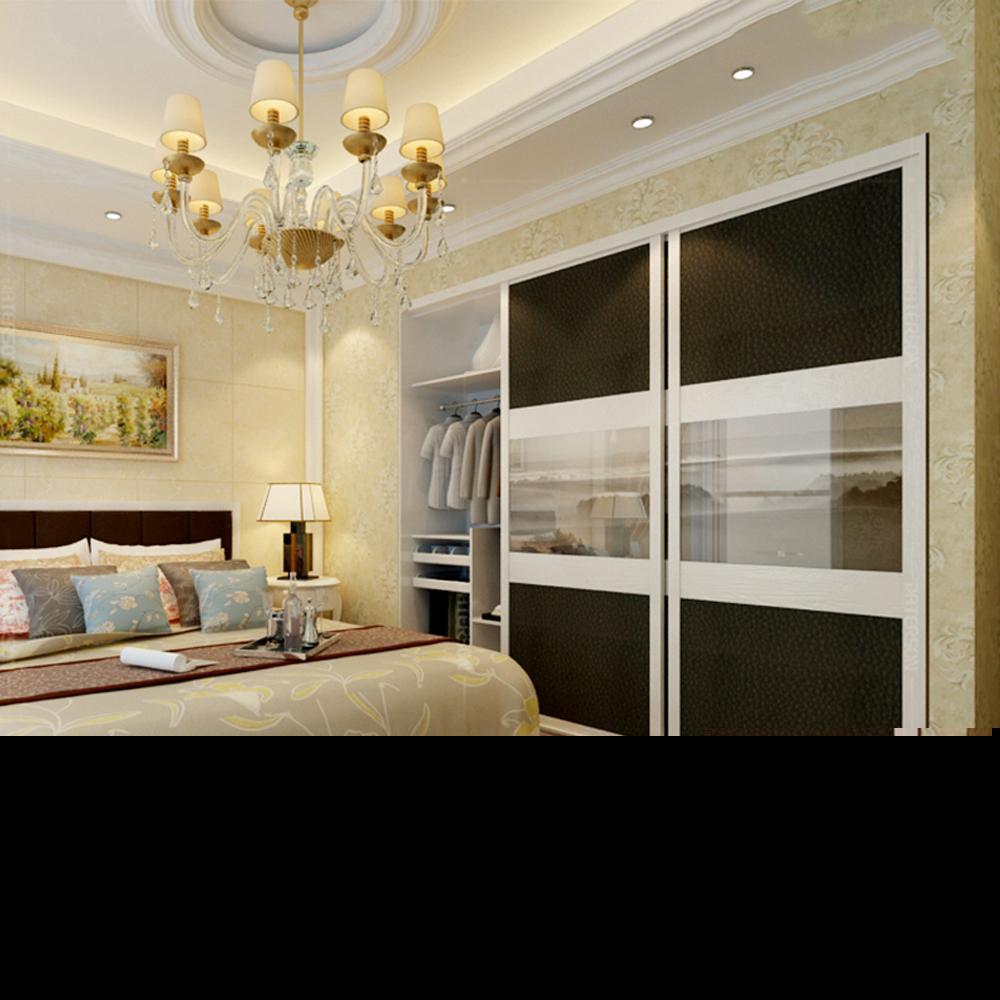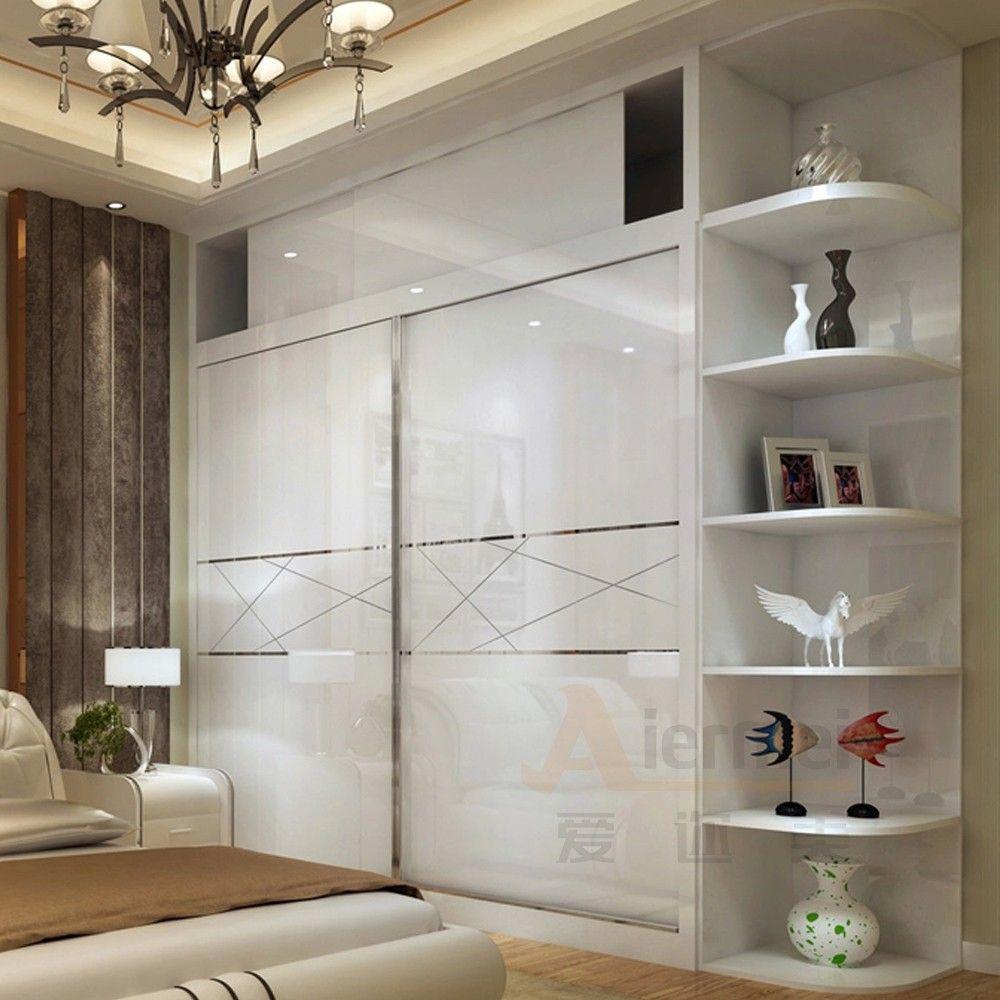The first image is the image on the left, the second image is the image on the right. Considering the images on both sides, is "The right image shows at least three earth-tone sliding doors with no embellishments." valid? Answer yes or no. No. 